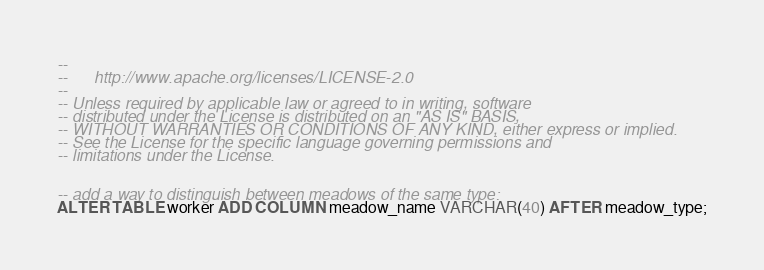Convert code to text. <code><loc_0><loc_0><loc_500><loc_500><_SQL_>-- 
--      http://www.apache.org/licenses/LICENSE-2.0
-- 
-- Unless required by applicable law or agreed to in writing, software
-- distributed under the License is distributed on an "AS IS" BASIS,
-- WITHOUT WARRANTIES OR CONDITIONS OF ANY KIND, either express or implied.
-- See the License for the specific language governing permissions and
-- limitations under the License.


-- add a way to distinguish between meadows of the same type:
ALTER TABLE worker ADD COLUMN meadow_name VARCHAR(40) AFTER meadow_type;
</code> 